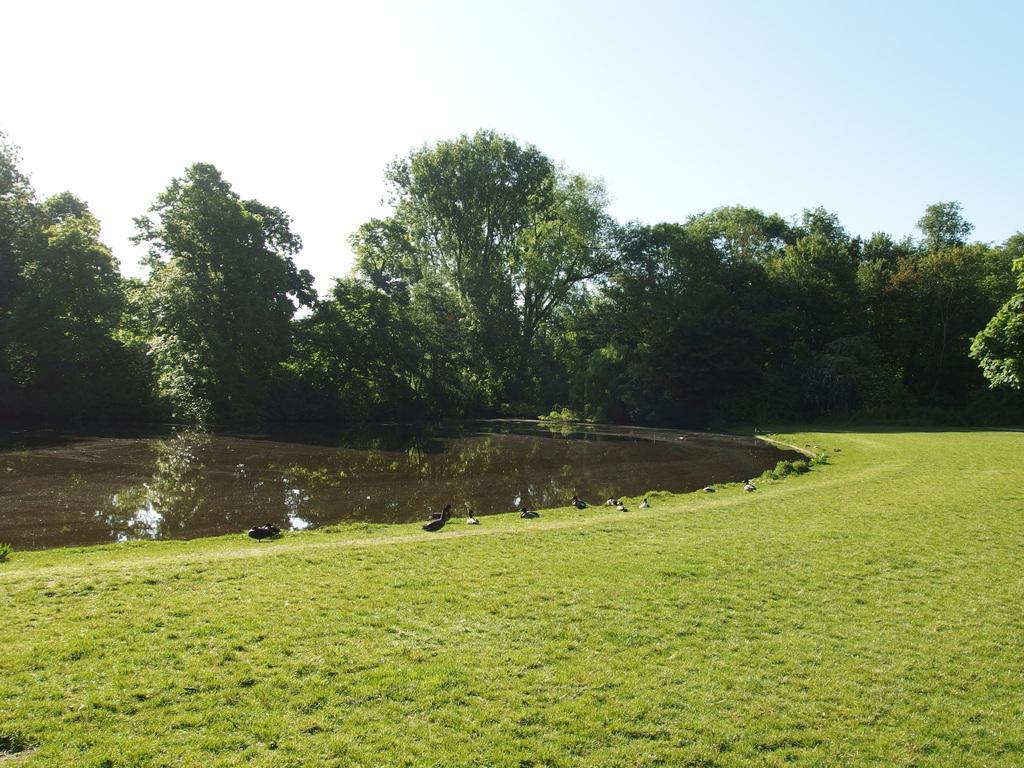Please provide a concise description of this image. In this image, we can see birds and in the background, there are trees. At the bottom, there is water and ground. 